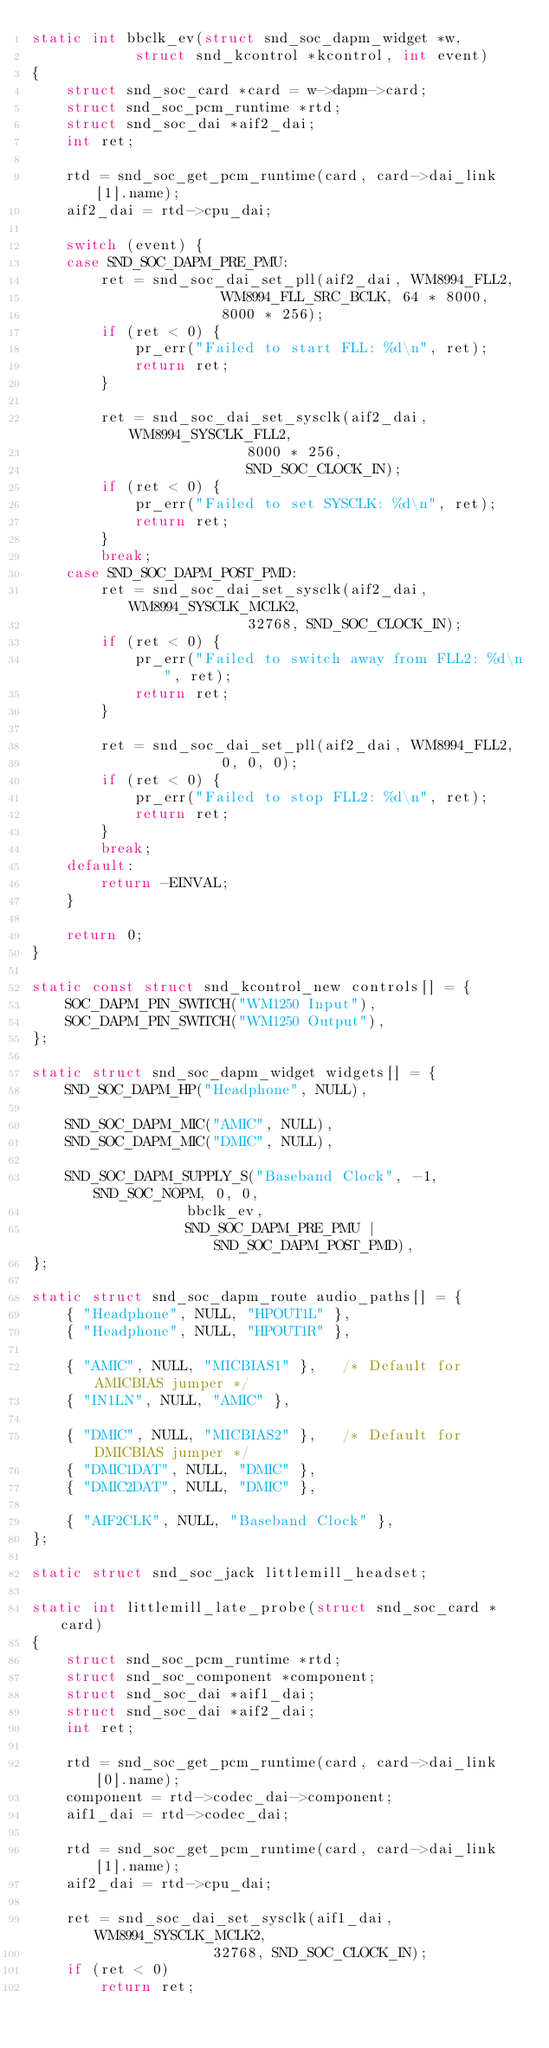Convert code to text. <code><loc_0><loc_0><loc_500><loc_500><_C_>static int bbclk_ev(struct snd_soc_dapm_widget *w,
		    struct snd_kcontrol *kcontrol, int event)
{
	struct snd_soc_card *card = w->dapm->card;
	struct snd_soc_pcm_runtime *rtd;
	struct snd_soc_dai *aif2_dai;
	int ret;

	rtd = snd_soc_get_pcm_runtime(card, card->dai_link[1].name);
	aif2_dai = rtd->cpu_dai;

	switch (event) {
	case SND_SOC_DAPM_PRE_PMU:
		ret = snd_soc_dai_set_pll(aif2_dai, WM8994_FLL2,
					  WM8994_FLL_SRC_BCLK, 64 * 8000,
					  8000 * 256);
		if (ret < 0) {
			pr_err("Failed to start FLL: %d\n", ret);
			return ret;
		}

		ret = snd_soc_dai_set_sysclk(aif2_dai, WM8994_SYSCLK_FLL2,
					     8000 * 256,
					     SND_SOC_CLOCK_IN);
		if (ret < 0) {
			pr_err("Failed to set SYSCLK: %d\n", ret);
			return ret;
		}
		break;
	case SND_SOC_DAPM_POST_PMD:
		ret = snd_soc_dai_set_sysclk(aif2_dai, WM8994_SYSCLK_MCLK2,
					     32768, SND_SOC_CLOCK_IN);
		if (ret < 0) {
			pr_err("Failed to switch away from FLL2: %d\n", ret);
			return ret;
		}

		ret = snd_soc_dai_set_pll(aif2_dai, WM8994_FLL2,
					  0, 0, 0);
		if (ret < 0) {
			pr_err("Failed to stop FLL2: %d\n", ret);
			return ret;
		}
		break;
	default:
		return -EINVAL;
	}

	return 0;
}

static const struct snd_kcontrol_new controls[] = {
	SOC_DAPM_PIN_SWITCH("WM1250 Input"),
	SOC_DAPM_PIN_SWITCH("WM1250 Output"),
};

static struct snd_soc_dapm_widget widgets[] = {
	SND_SOC_DAPM_HP("Headphone", NULL),

	SND_SOC_DAPM_MIC("AMIC", NULL),
	SND_SOC_DAPM_MIC("DMIC", NULL),

	SND_SOC_DAPM_SUPPLY_S("Baseband Clock", -1, SND_SOC_NOPM, 0, 0,
			      bbclk_ev,
			      SND_SOC_DAPM_PRE_PMU | SND_SOC_DAPM_POST_PMD),
};

static struct snd_soc_dapm_route audio_paths[] = {
	{ "Headphone", NULL, "HPOUT1L" },
	{ "Headphone", NULL, "HPOUT1R" },

	{ "AMIC", NULL, "MICBIAS1" },   /* Default for AMICBIAS jumper */
	{ "IN1LN", NULL, "AMIC" },

	{ "DMIC", NULL, "MICBIAS2" },   /* Default for DMICBIAS jumper */
	{ "DMIC1DAT", NULL, "DMIC" },
	{ "DMIC2DAT", NULL, "DMIC" },

	{ "AIF2CLK", NULL, "Baseband Clock" },
};

static struct snd_soc_jack littlemill_headset;

static int littlemill_late_probe(struct snd_soc_card *card)
{
	struct snd_soc_pcm_runtime *rtd;
	struct snd_soc_component *component;
	struct snd_soc_dai *aif1_dai;
	struct snd_soc_dai *aif2_dai;
	int ret;

	rtd = snd_soc_get_pcm_runtime(card, card->dai_link[0].name);
	component = rtd->codec_dai->component;
	aif1_dai = rtd->codec_dai;

	rtd = snd_soc_get_pcm_runtime(card, card->dai_link[1].name);
	aif2_dai = rtd->cpu_dai;

	ret = snd_soc_dai_set_sysclk(aif1_dai, WM8994_SYSCLK_MCLK2,
				     32768, SND_SOC_CLOCK_IN);
	if (ret < 0)
		return ret;
</code> 